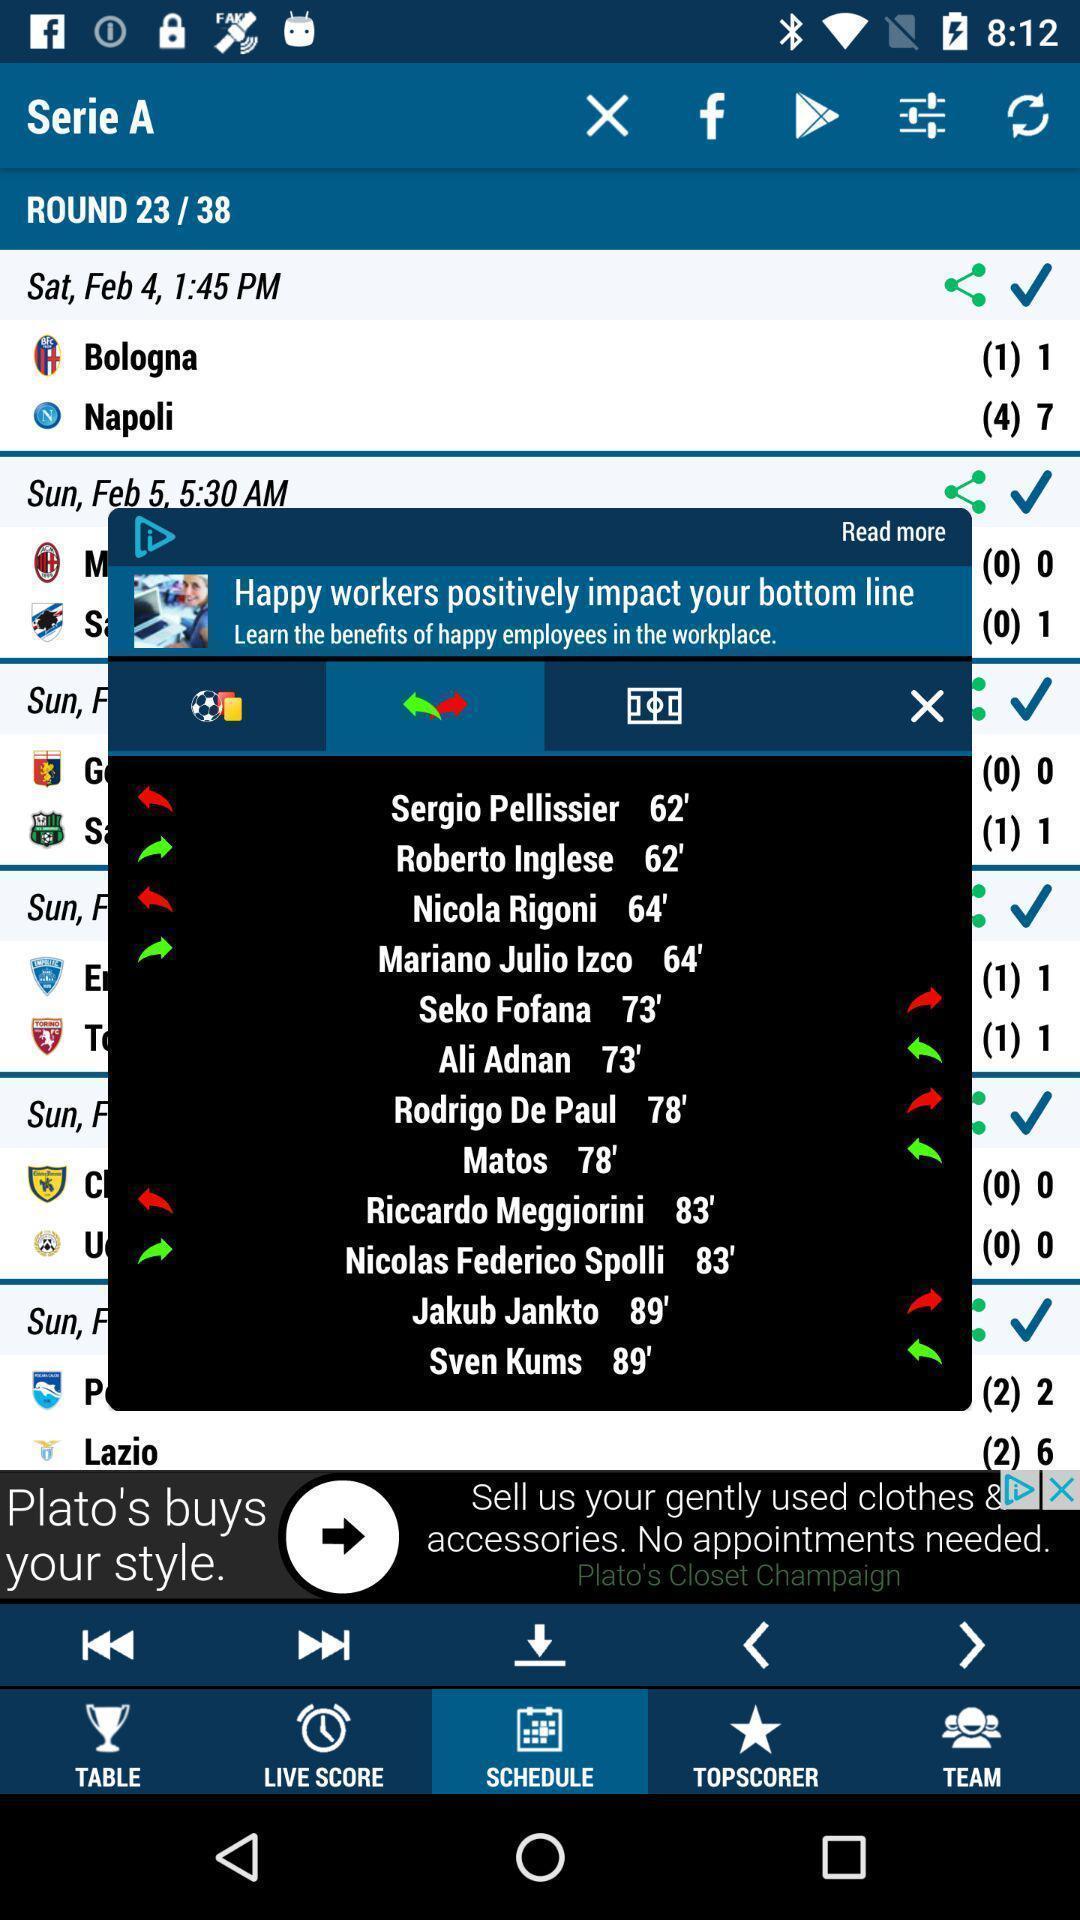Provide a description of this screenshot. Pop up of happy workers positively impact bottom line. 